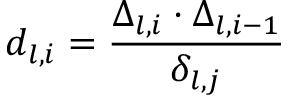<formula> <loc_0><loc_0><loc_500><loc_500>d _ { l , i } = \frac { \Delta _ { l , i } \cdot \Delta _ { l , i - 1 } } { \delta _ { l , j } }</formula> 